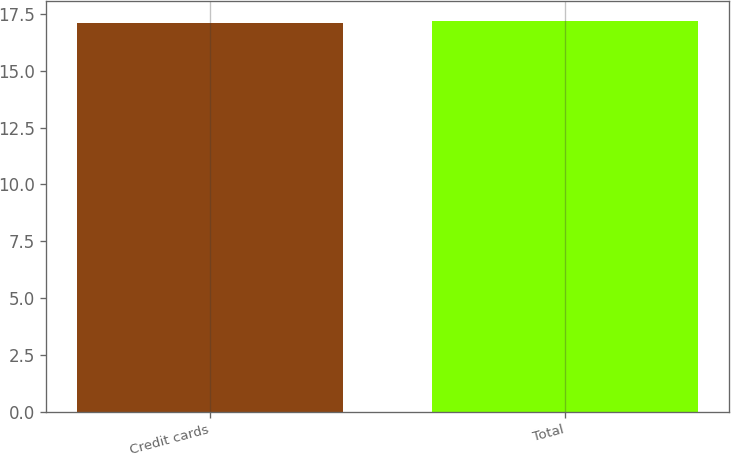Convert chart to OTSL. <chart><loc_0><loc_0><loc_500><loc_500><bar_chart><fcel>Credit cards<fcel>Total<nl><fcel>17.1<fcel>17.2<nl></chart> 